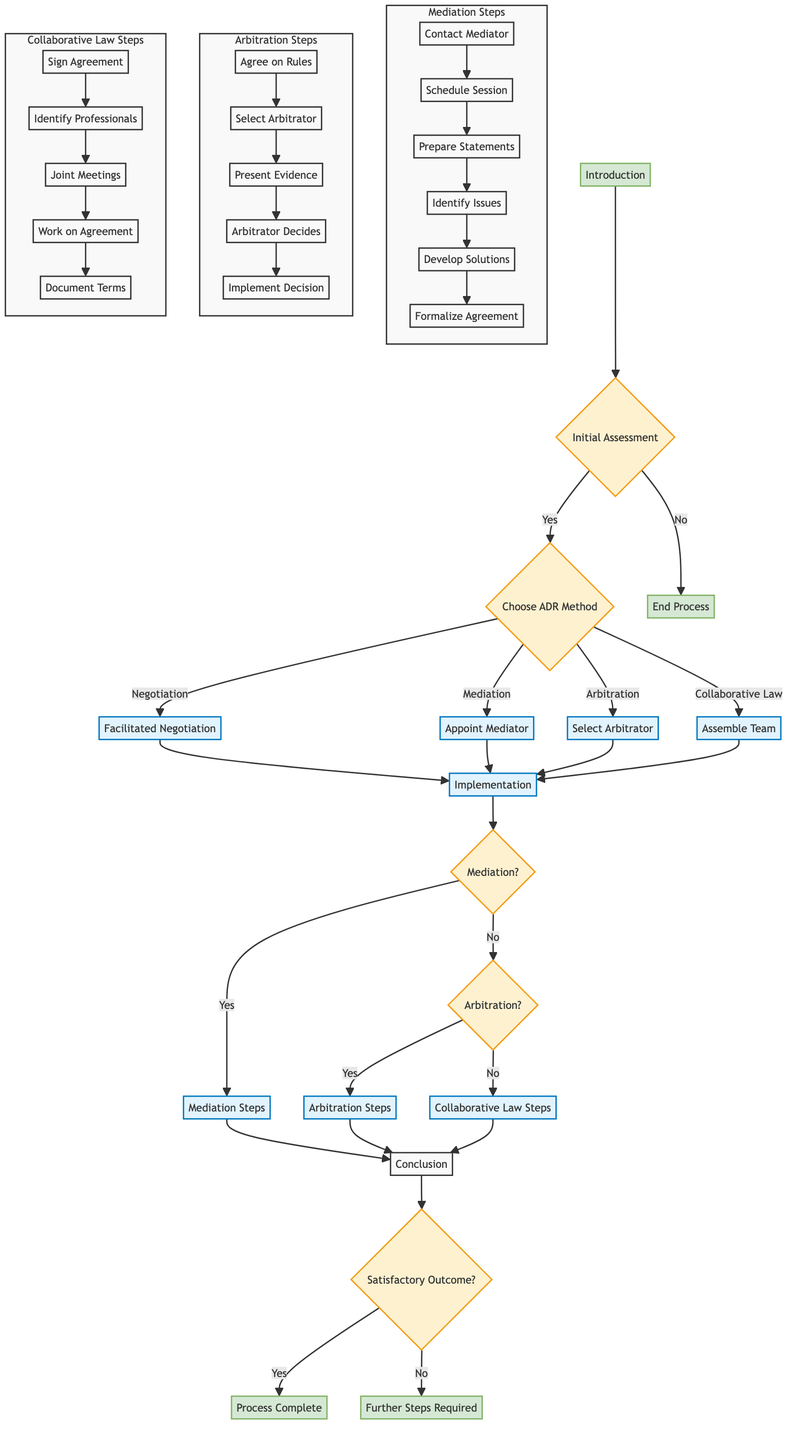What is the first step in the flow chart? The first step in the flow chart is titled "Introduction." This step outlines the initial process of identifying the nature and scope of the conflict before any assessments can be made.
Answer: Introduction How many ADR methods are presented in the flow chart? The flow chart presents four ADR methods: Negotiation, Mediation, Arbitration, and Collaborative Law. These are specified in the section "Choose ADR Method."
Answer: Four What action follows the selection of "Mediation"? After selecting "Mediation," the next action is to "Appoint Mediator." This decision leads directly to a step in the implementation process.
Answer: Appoint Mediator What happens if the answer to "Is the conflict suitable for ADR?" is "No"? If the answer is "No," the flow chart directs to "End Process," indicating that no further action will be taken regarding ADR for this conflict.
Answer: End Process Which method requires a trained neutral third-party? The method that requires a trained neutral third-party is "Mediation." It specifically mentions the need for a mediator in the criteria listed under the Choosing the ADR Method section.
Answer: Mediation What steps should be taken after appointing a mediator? After appointing a mediator, the next steps involve scheduling the initial mediation session, preparing opening statements, identifying key issues, developing mutually acceptable solutions, and formalizing the agreement in writing.
Answer: Schedule Session If "Mediation" is chosen, which node immediately follows? If "Mediation" is chosen, the node that immediately follows is "Mediation Steps," which outlines the detailed steps necessary to implement the mediation process.
Answer: Mediation Steps What is evaluated to decide if ADR is suitable? The evaluation focuses on whether the conflict is suitable for ADR and if the parties have agreed to pursue it. These assessments are conducted during the "Initial Assessment" step of the flowchart.
Answer: Conflict Suitability and Party Agreement What happens after "Conclusion" if the outcome is not satisfactory? If the outcome is not satisfactory, the next step is "Further Steps Required," indicating that additional actions or measures need to be taken to address the unresolved issues.
Answer: Further Steps Required 